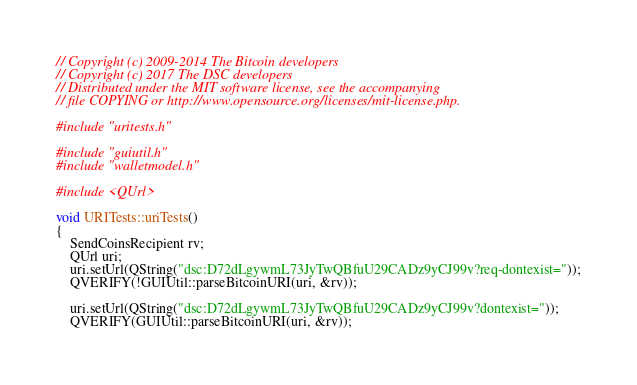<code> <loc_0><loc_0><loc_500><loc_500><_C++_>// Copyright (c) 2009-2014 The Bitcoin developers
// Copyright (c) 2017 The DSC developers
// Distributed under the MIT software license, see the accompanying
// file COPYING or http://www.opensource.org/licenses/mit-license.php.

#include "uritests.h"

#include "guiutil.h"
#include "walletmodel.h"

#include <QUrl>

void URITests::uriTests()
{
    SendCoinsRecipient rv;
    QUrl uri;
    uri.setUrl(QString("dsc:D72dLgywmL73JyTwQBfuU29CADz9yCJ99v?req-dontexist="));
    QVERIFY(!GUIUtil::parseBitcoinURI(uri, &rv));

    uri.setUrl(QString("dsc:D72dLgywmL73JyTwQBfuU29CADz9yCJ99v?dontexist="));
    QVERIFY(GUIUtil::parseBitcoinURI(uri, &rv));</code> 